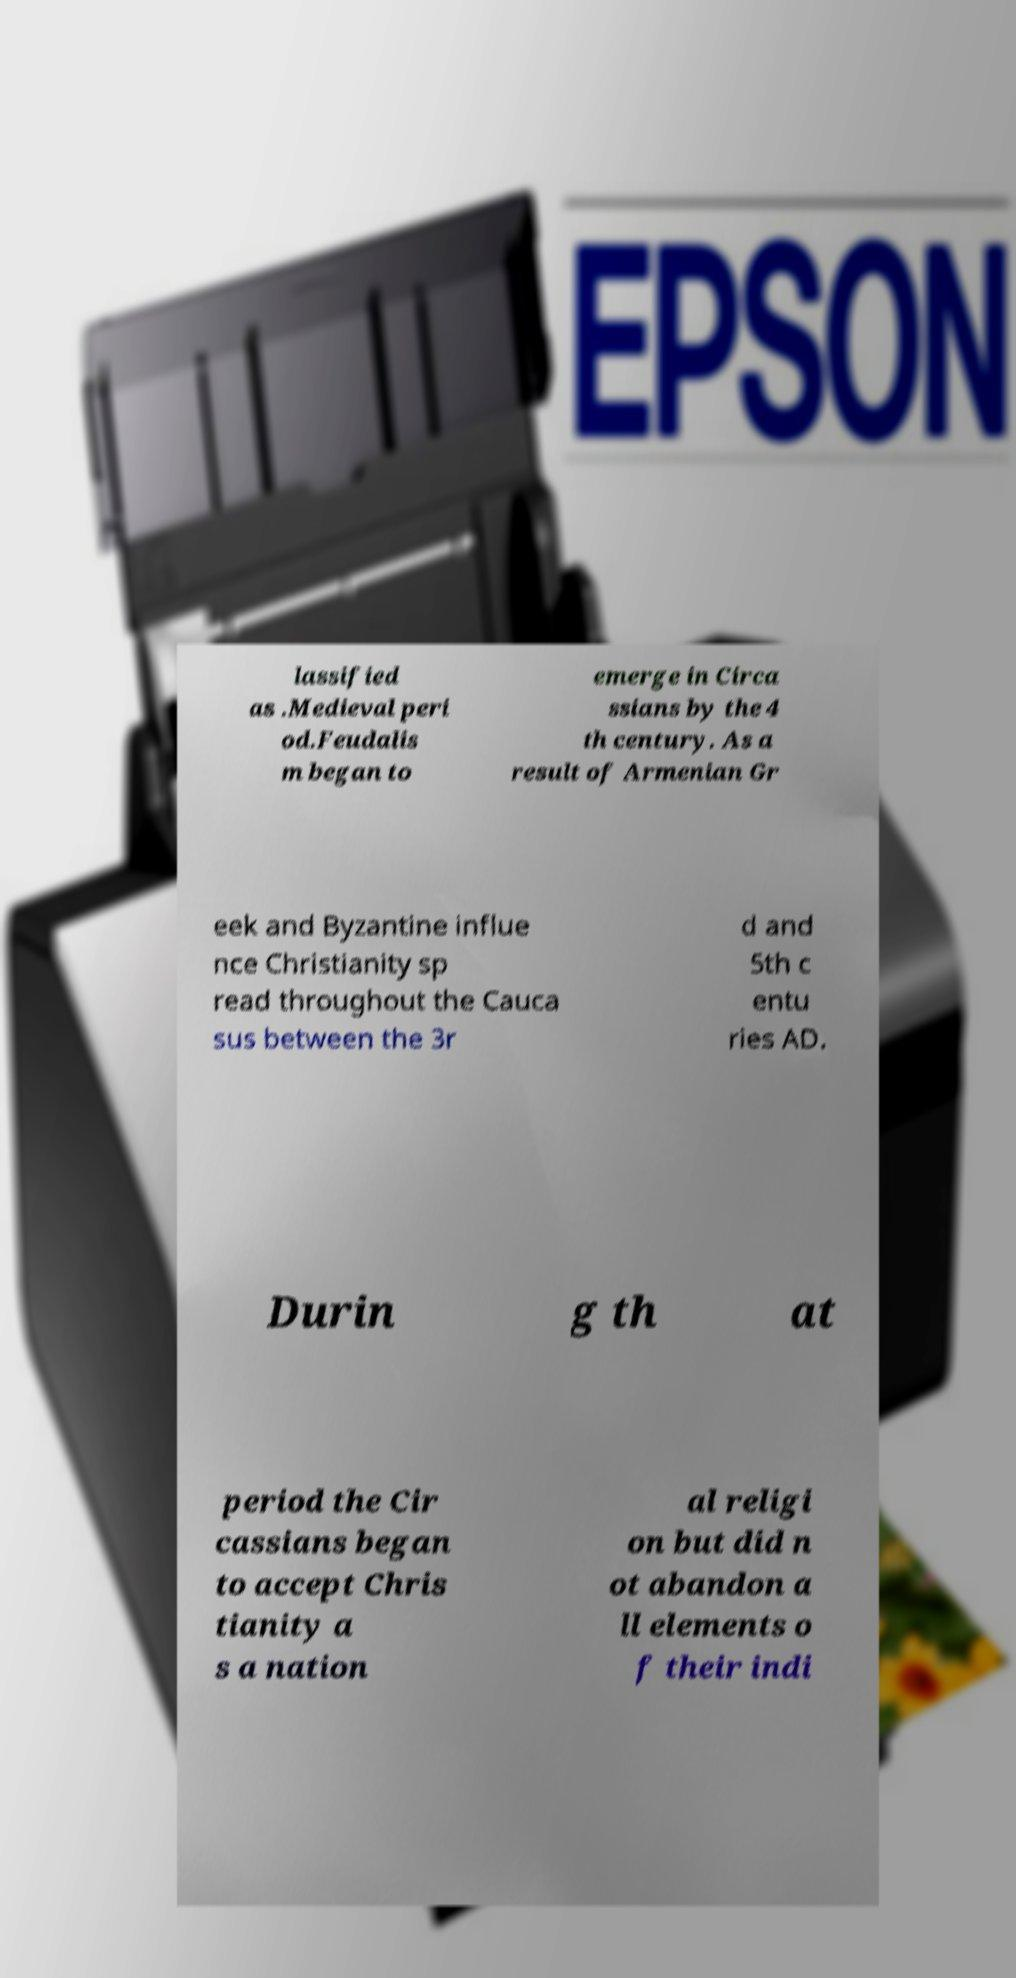I need the written content from this picture converted into text. Can you do that? lassified as .Medieval peri od.Feudalis m began to emerge in Circa ssians by the 4 th century. As a result of Armenian Gr eek and Byzantine influe nce Christianity sp read throughout the Cauca sus between the 3r d and 5th c entu ries AD. Durin g th at period the Cir cassians began to accept Chris tianity a s a nation al religi on but did n ot abandon a ll elements o f their indi 